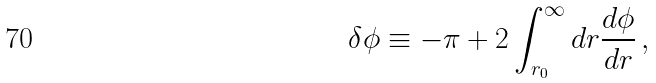<formula> <loc_0><loc_0><loc_500><loc_500>\delta \phi \equiv - \pi + 2 \int _ { r _ { 0 } } ^ { \infty } d r \frac { d \phi } { d r } \, ,</formula> 